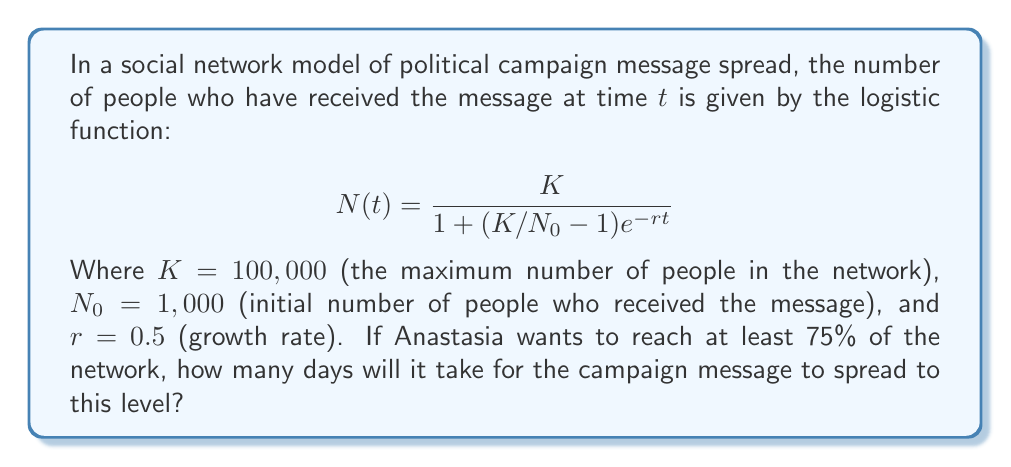Show me your answer to this math problem. To solve this problem, we need to follow these steps:

1) First, we need to determine the target number of people:
   75% of 100,000 = 0.75 * 100,000 = 75,000 people

2) Now, we need to solve the equation:

   $$75,000 = \frac{100,000}{1 + (100,000/1,000 - 1)e^{-0.5t}}$$

3) Let's simplify the right side:

   $$75,000 = \frac{100,000}{1 + 99e^{-0.5t}}$$

4) Multiply both sides by the denominator:

   $$75,000(1 + 99e^{-0.5t}) = 100,000$$

5) Expand:

   $$75,000 + 7,425,000e^{-0.5t} = 100,000$$

6) Subtract 75,000 from both sides:

   $$7,425,000e^{-0.5t} = 25,000$$

7) Divide both sides by 7,425,000:

   $$e^{-0.5t} = \frac{1}{297}$$

8) Take natural log of both sides:

   $$-0.5t = \ln(\frac{1}{297})$$

9) Divide both sides by -0.5:

   $$t = -\frac{\ln(\frac{1}{297})}{0.5} = \frac{\ln(297)}{0.5}$$

10) Calculate the final result:

    $$t = \frac{5.69373}{0.5} \approx 11.39 \text{ days}$$

Therefore, it will take approximately 11.39 days for the campaign message to reach 75% of the network.
Answer: 11.39 days 